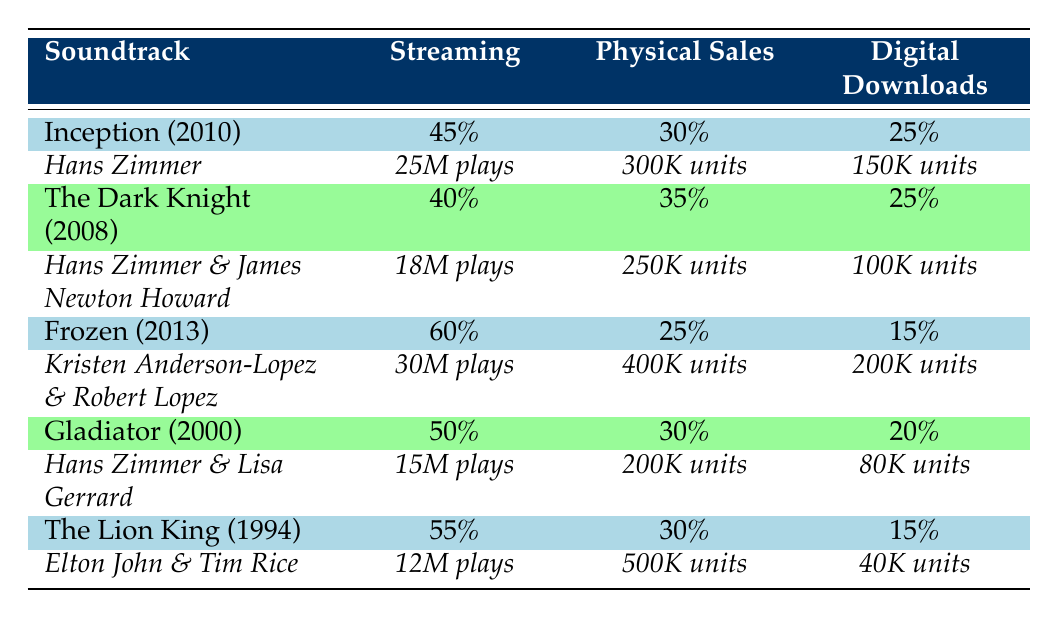What is the total number of plays for "Frozen"? The table indicates that "Frozen" has received 30 million plays on streaming.
Answer: 30 million plays Which soundtrack had the highest percentage of streaming plays? By examining the percentages in the streaming column, "Frozen" has the highest at 60%.
Answer: "Frozen" Was "The Lion King" more successful in physical sales compared to "The Dark Knight"? "The Lion King" sold 500,000 units while "The Dark Knight" sold 250,000 units; thus, "The Lion King" was indeed more successful in physical sales.
Answer: Yes What is the average percentage of digital downloads across all soundtracks? Adding the percentages of digital downloads: 25 + 25 + 15 + 20 + 15 = 100. Dividing by 5 (the number of soundtracks) gives an average of 20%.
Answer: 20% Did "Gladiator" have more streaming plays than "The Dark Knight"? "Gladiator" has 15 million plays while "The Dark Knight" has 18 million plays; therefore, "Gladiator" did not have more streaming plays.
Answer: No What is the difference in physical sales between "Inception" and "Frozen"? "Inception" sold 300,000 units and "Frozen" sold 400,000 units; the difference is 400,000 - 300,000 = 100,000 units.
Answer: 100,000 units Which soundtrack had the lowest percentage of digital downloads? Upon reviewing the percentages, "Frozen" has the lowest at 15% for digital downloads.
Answer: "Frozen" Calculate the total number of units sold (physical sales) for all the soundtracks combined. Adding the physical sales: 300K (Inception) + 250K (Dark Knight) + 400K (Frozen) + 200K (Gladiator) + 500K (Lion King) gives a total of 1,650,000 units sold.
Answer: 1,650,000 units 